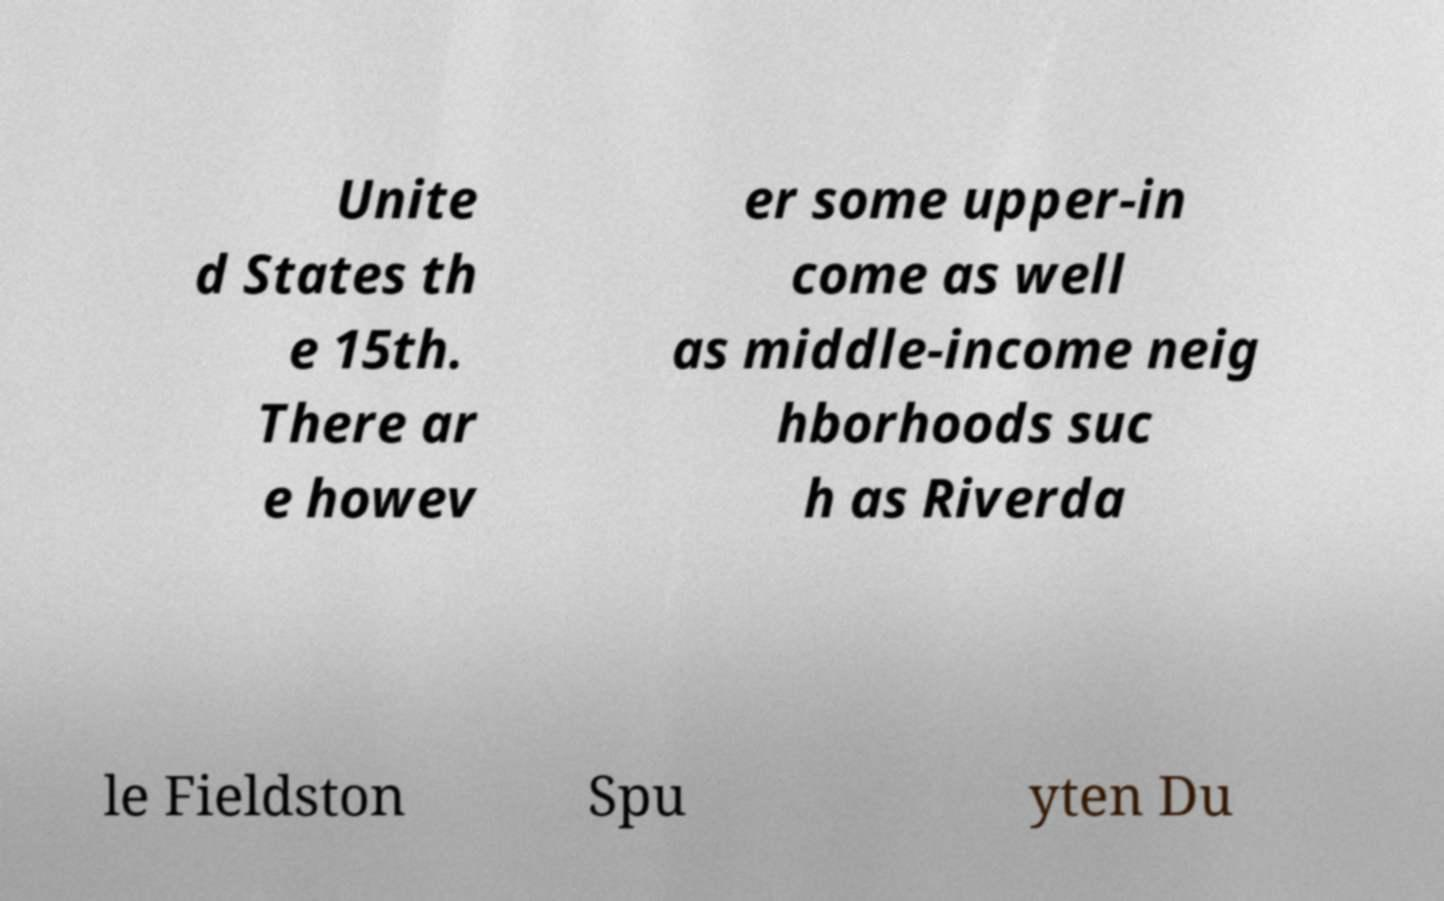There's text embedded in this image that I need extracted. Can you transcribe it verbatim? Unite d States th e 15th. There ar e howev er some upper-in come as well as middle-income neig hborhoods suc h as Riverda le Fieldston Spu yten Du 